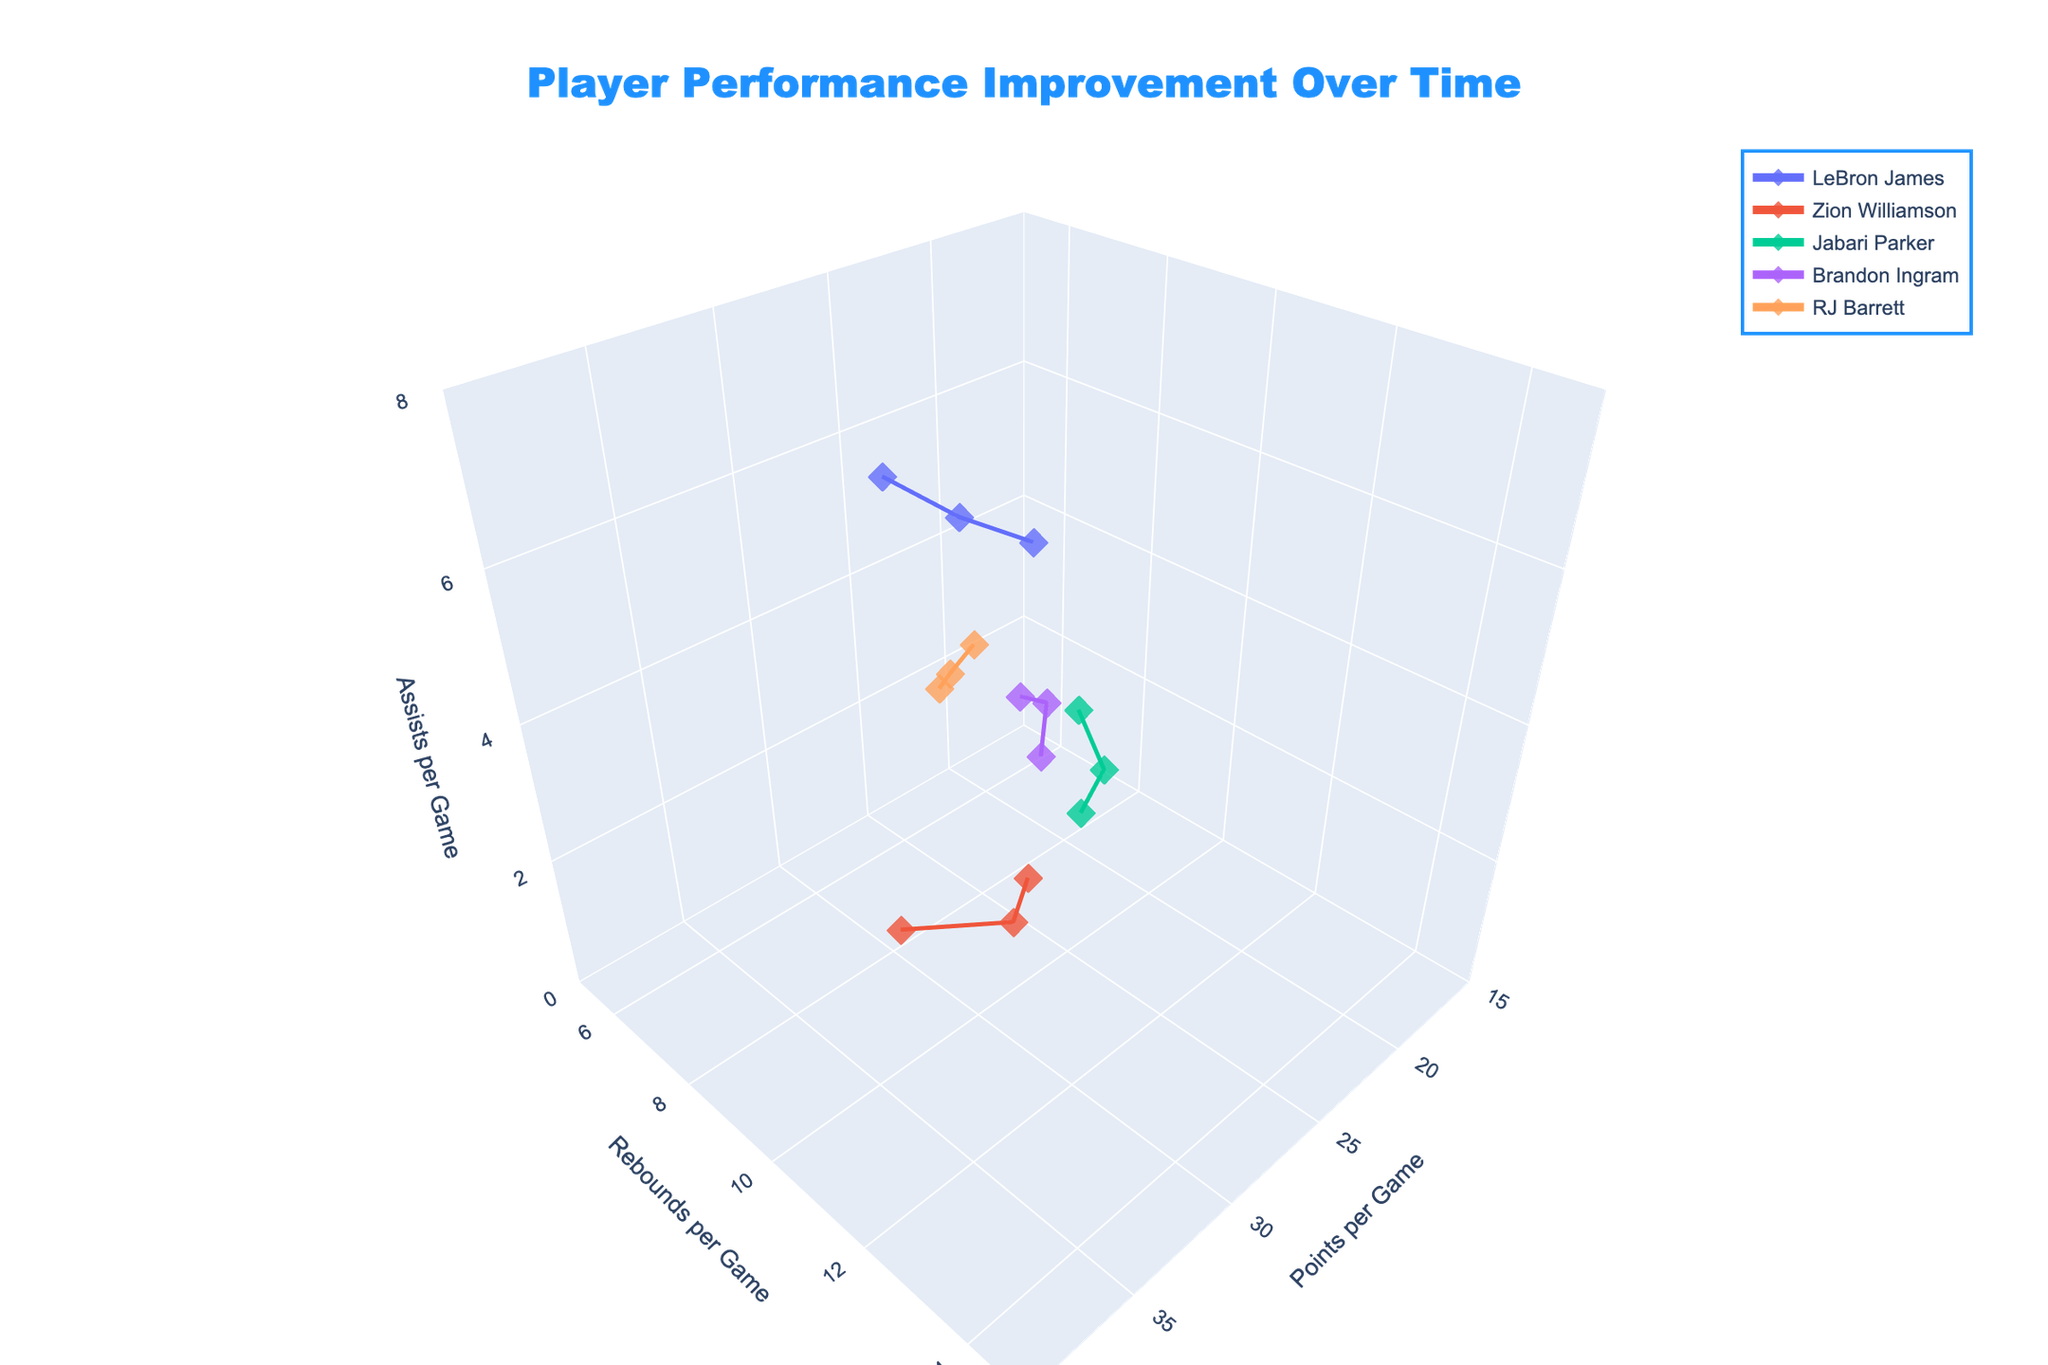What color is the line representing LeBron James? Look for the line in the 3D plot with LeBron James's name. Note the color used in the line connected to the data points for his performance.
Answer: The color used can vary but is one of the distinct colors from the qualitative color set used in the plot What is the range of assists per game for all players combined? Check the z-axis labels that represent assists per game and note the minimum and maximum values. The range should cover from the lowest to the highest point indicated on the z-axis.
Answer: 0 to 8 Which player showed the highest increase in points per game from one year to the next? Compare the increase in points per game year-over-year for each player, and identify the player with the highest single-year increase.
Answer: Zion Williamson How do the average rebounds per game compare between Jabari Parker and Brandon Ingram over all their years shown? Calculate the average rebounds per game for both Jabari Parker and Brandon Ingram by summing their rebounds per game values and dividing by the number of years shown.
Answer: Jabari Parker: 10.13, Brandon Ingram: 9.03 Which player has the least variation in rebounds per game over the years shown? Look at the spread of data points on the y-axis for each player and determine the one with the smallest range (difference between the maximum and minimum values).
Answer: LeBron James What is the total number of data points plotted? Count the total number of individual data points plotted in the 3D scatter plot (each year for every player).
Answer: 15 Which player achieved the highest assists per game in any single year? Identify the maximum assists per game value and the corresponding player by examining the z-axis values and comparing them.
Answer: LeBron James (7.3) Compare LeBron James and Zion Williamson in terms of their maximum points per game achieved. Who had more? Identify the highest points per game value for both LeBron James and Zion Williamson by checking the x-axis values and determine who had the higher value.
Answer: Zion Williamson (36.4 vs. 31.6) What is the average number of points per game for RJ Barrett over the years shown? Sum the points per game values for RJ Barrett across the years shown and divide by the number of years to get the average.
Answer: (22.4+27.1+30.5)/3 = 26.67 Which player had the highest average assists per game over the years? Calculate the average assists per game for each player by summing their assists values and dividing by the number of years, then compare them to find the player with the highest average.
Answer: LeBron James (5.70) 